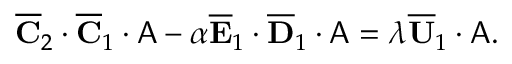<formula> <loc_0><loc_0><loc_500><loc_500>\begin{array} { r } { \overline { C } _ { 2 } \cdot \overline { C } _ { 1 } \cdot A - \alpha \overline { E } _ { 1 } \cdot \overline { D } _ { 1 } \cdot A = \lambda \overline { U } _ { 1 } \cdot A . } \end{array}</formula> 